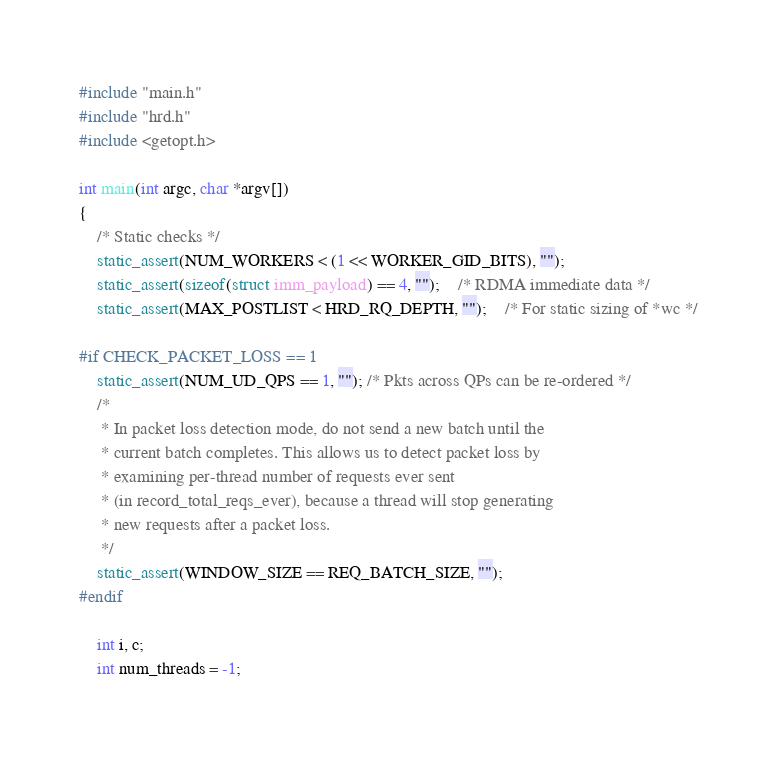<code> <loc_0><loc_0><loc_500><loc_500><_C++_>#include "main.h"
#include "hrd.h"
#include <getopt.h>

int main(int argc, char *argv[])
{
	/* Static checks */
	static_assert(NUM_WORKERS < (1 << WORKER_GID_BITS), "");
	static_assert(sizeof(struct imm_payload) == 4, "");	/* RDMA immediate data */
	static_assert(MAX_POSTLIST < HRD_RQ_DEPTH, "");	/* For static sizing of *wc */

#if CHECK_PACKET_LOSS == 1
	static_assert(NUM_UD_QPS == 1, ""); /* Pkts across QPs can be re-ordered */
	/*
	 * In packet loss detection mode, do not send a new batch until the
	 * current batch completes. This allows us to detect packet loss by
	 * examining per-thread number of requests ever sent
	 * (in record_total_reqs_ever), because a thread will stop generating
	 * new requests after a packet loss.
	 */
	static_assert(WINDOW_SIZE == REQ_BATCH_SIZE, "");
#endif

	int i, c;
	int num_threads = -1;</code> 